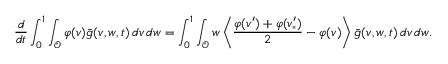Convert formula to latex. <formula><loc_0><loc_0><loc_500><loc_500>\frac { d } { d t } \int _ { 0 } ^ { 1 } \int _ { \mathcal { O } } \varphi ( v ) \bar { g } ( v , w , t ) \, d v \, d w = \int _ { 0 } ^ { 1 } \int _ { \mathcal { O } } w \left \langle \frac { \varphi ( v ^ { \prime } ) + \varphi ( v _ { \ast } ^ { \prime } ) } { 2 } - \varphi ( v ) \right \rangle \bar { g } ( v , w , t ) \, d v \, d w .</formula> 